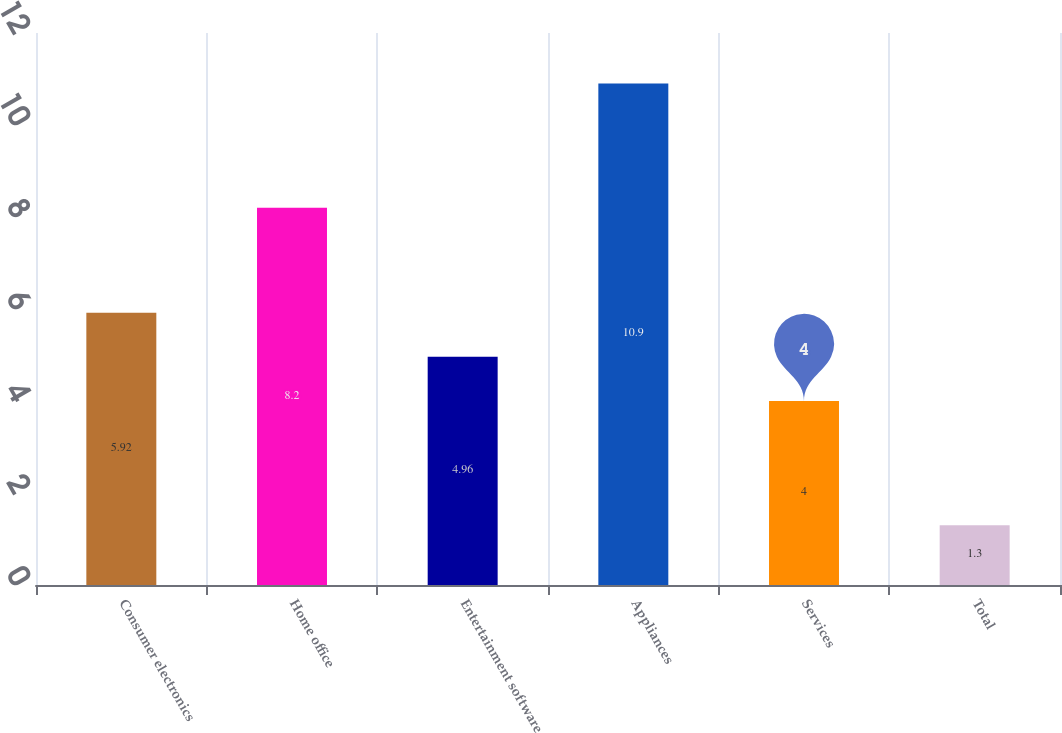<chart> <loc_0><loc_0><loc_500><loc_500><bar_chart><fcel>Consumer electronics<fcel>Home office<fcel>Entertainment software<fcel>Appliances<fcel>Services<fcel>Total<nl><fcel>5.92<fcel>8.2<fcel>4.96<fcel>10.9<fcel>4<fcel>1.3<nl></chart> 